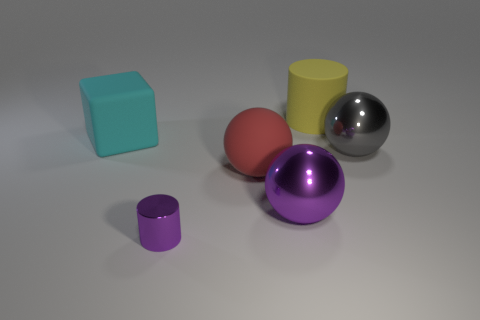There is a purple metal object behind the small object; is its shape the same as the matte object that is behind the large cyan rubber object?
Provide a short and direct response. No. Are there any gray balls that have the same size as the yellow thing?
Offer a terse response. Yes. What is the large thing left of the tiny metal thing made of?
Make the answer very short. Rubber. Is the large thing right of the large yellow object made of the same material as the small purple cylinder?
Provide a short and direct response. Yes. Are there any large brown metallic cubes?
Offer a terse response. No. There is a tiny object that is made of the same material as the big gray sphere; what color is it?
Make the answer very short. Purple. There is a sphere on the left side of the metallic sphere that is left of the cylinder that is behind the cyan matte thing; what is its color?
Offer a very short reply. Red. There is a red rubber ball; is its size the same as the cylinder that is behind the large rubber block?
Your answer should be compact. Yes. What number of objects are either purple objects left of the rubber ball or objects that are right of the red object?
Provide a short and direct response. 4. The purple metallic object that is the same size as the yellow cylinder is what shape?
Provide a short and direct response. Sphere. 